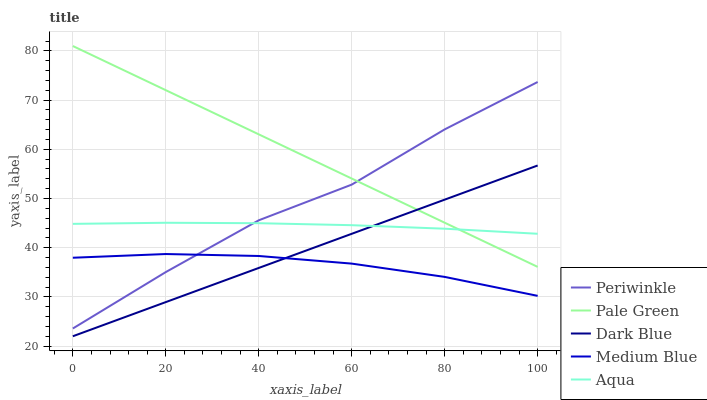Does Medium Blue have the minimum area under the curve?
Answer yes or no. Yes. Does Pale Green have the maximum area under the curve?
Answer yes or no. Yes. Does Dark Blue have the minimum area under the curve?
Answer yes or no. No. Does Dark Blue have the maximum area under the curve?
Answer yes or no. No. Is Dark Blue the smoothest?
Answer yes or no. Yes. Is Periwinkle the roughest?
Answer yes or no. Yes. Is Pale Green the smoothest?
Answer yes or no. No. Is Pale Green the roughest?
Answer yes or no. No. Does Dark Blue have the lowest value?
Answer yes or no. Yes. Does Pale Green have the lowest value?
Answer yes or no. No. Does Pale Green have the highest value?
Answer yes or no. Yes. Does Dark Blue have the highest value?
Answer yes or no. No. Is Medium Blue less than Pale Green?
Answer yes or no. Yes. Is Periwinkle greater than Dark Blue?
Answer yes or no. Yes. Does Pale Green intersect Aqua?
Answer yes or no. Yes. Is Pale Green less than Aqua?
Answer yes or no. No. Is Pale Green greater than Aqua?
Answer yes or no. No. Does Medium Blue intersect Pale Green?
Answer yes or no. No. 